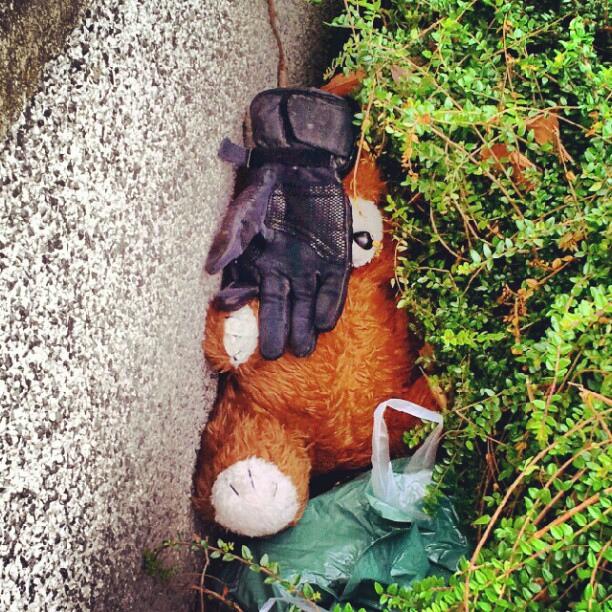What is on top of the stuffed bear?
Answer briefly. Glove. Do you think this stuffed animal is sentimental?
Write a very short answer. No. Is this stuffed animal inside?
Short answer required. No. 